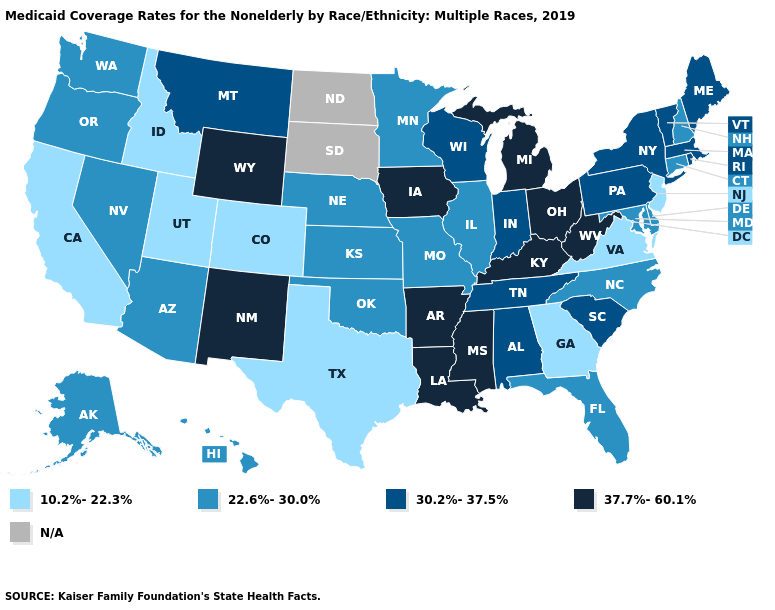What is the lowest value in states that border Ohio?
Keep it brief. 30.2%-37.5%. Name the states that have a value in the range 10.2%-22.3%?
Answer briefly. California, Colorado, Georgia, Idaho, New Jersey, Texas, Utah, Virginia. Name the states that have a value in the range 22.6%-30.0%?
Give a very brief answer. Alaska, Arizona, Connecticut, Delaware, Florida, Hawaii, Illinois, Kansas, Maryland, Minnesota, Missouri, Nebraska, Nevada, New Hampshire, North Carolina, Oklahoma, Oregon, Washington. Name the states that have a value in the range 30.2%-37.5%?
Quick response, please. Alabama, Indiana, Maine, Massachusetts, Montana, New York, Pennsylvania, Rhode Island, South Carolina, Tennessee, Vermont, Wisconsin. What is the value of North Dakota?
Be succinct. N/A. Name the states that have a value in the range 30.2%-37.5%?
Quick response, please. Alabama, Indiana, Maine, Massachusetts, Montana, New York, Pennsylvania, Rhode Island, South Carolina, Tennessee, Vermont, Wisconsin. What is the lowest value in the MidWest?
Short answer required. 22.6%-30.0%. Name the states that have a value in the range 22.6%-30.0%?
Quick response, please. Alaska, Arizona, Connecticut, Delaware, Florida, Hawaii, Illinois, Kansas, Maryland, Minnesota, Missouri, Nebraska, Nevada, New Hampshire, North Carolina, Oklahoma, Oregon, Washington. Does New Mexico have the lowest value in the West?
Short answer required. No. Name the states that have a value in the range 22.6%-30.0%?
Concise answer only. Alaska, Arizona, Connecticut, Delaware, Florida, Hawaii, Illinois, Kansas, Maryland, Minnesota, Missouri, Nebraska, Nevada, New Hampshire, North Carolina, Oklahoma, Oregon, Washington. Does Mississippi have the highest value in the USA?
Answer briefly. Yes. Among the states that border Vermont , does Massachusetts have the highest value?
Keep it brief. Yes. What is the value of Mississippi?
Concise answer only. 37.7%-60.1%. Name the states that have a value in the range 37.7%-60.1%?
Write a very short answer. Arkansas, Iowa, Kentucky, Louisiana, Michigan, Mississippi, New Mexico, Ohio, West Virginia, Wyoming. 